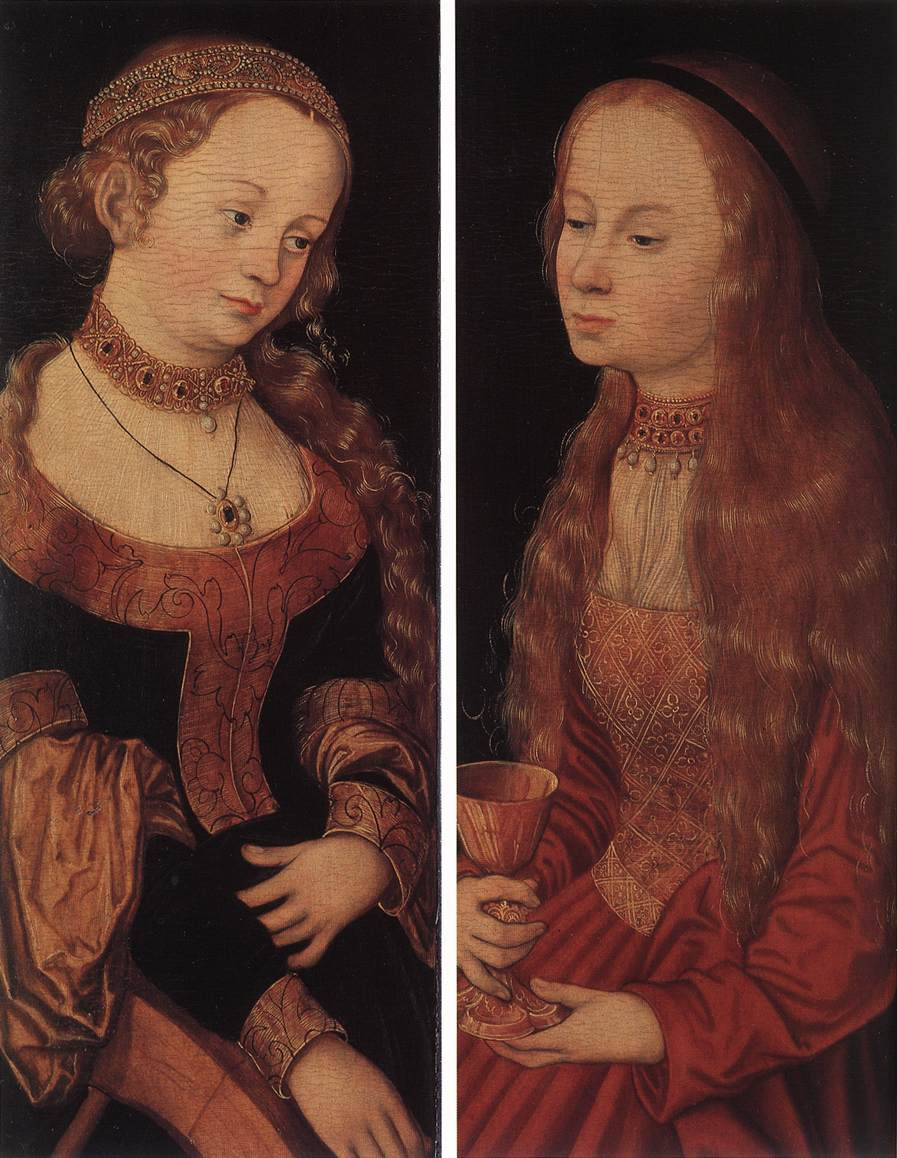What would you expect to find if you could step into this painting? Stepping into the painting, one might find themselves in an opulent Renaissance chamber. The air is filled with a mix of incense and the scent of old, treasured books. The soft flicker of candlelight illuminates the detailed patterns of the rich tapestries adorning the walls. These tapestries depict historical battles and serene landscapes, creating a palpable sense of history and culture.

The women, now animated, glance towards you with curious and knowing eyes. The blonde woman may offer you her book, its pages aged but filled with wisdom that spans centuries. The red-haired woman extends her chalice, suggesting a form of initiation or a sharing of hidden knowledge. Each object and garment detail invites closer scrutiny, revealing stories within stories – a narrative rich in symbolism, artistry, and the serene sophistication characteristic of the Northern Renaissance. 